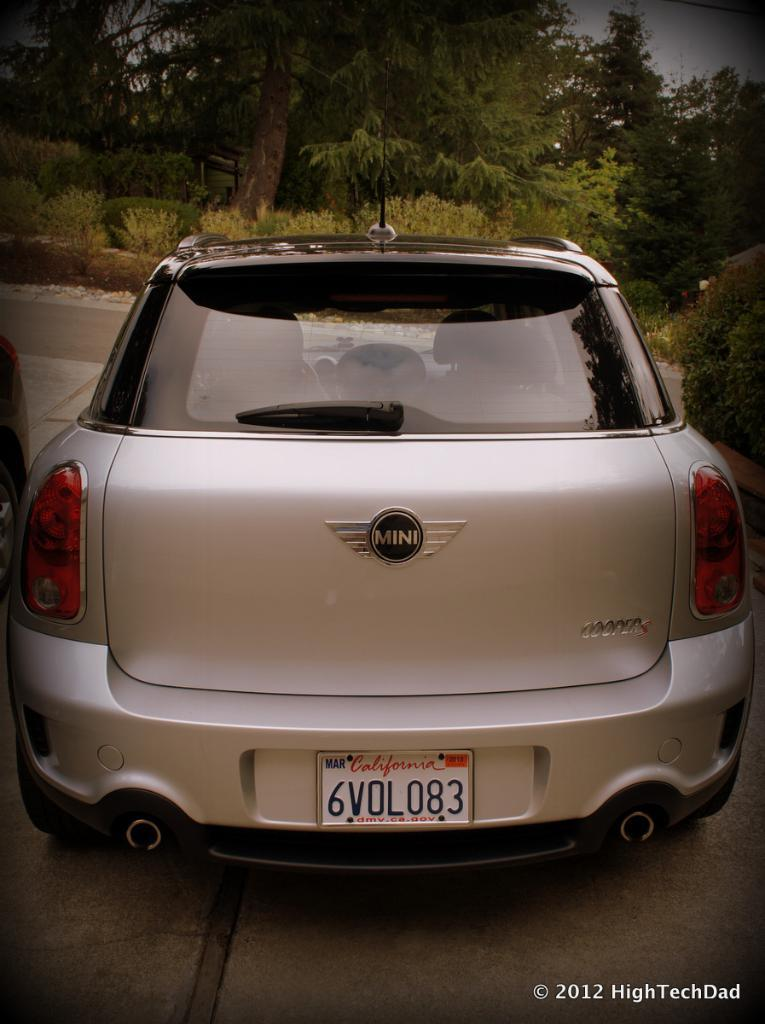What color is the car in the image? The car in the image is silver in color. Where is the car located in the image? The car is on the side of the road in the image. What can be seen in front of the car? There are many trees and plants in front of the car in the image. Is the car in the image being used as a jail for criminals? No, the car in the image is not being used as a jail for criminals. The image only shows a silver color car on the side of the road with trees and plants in front of it. 